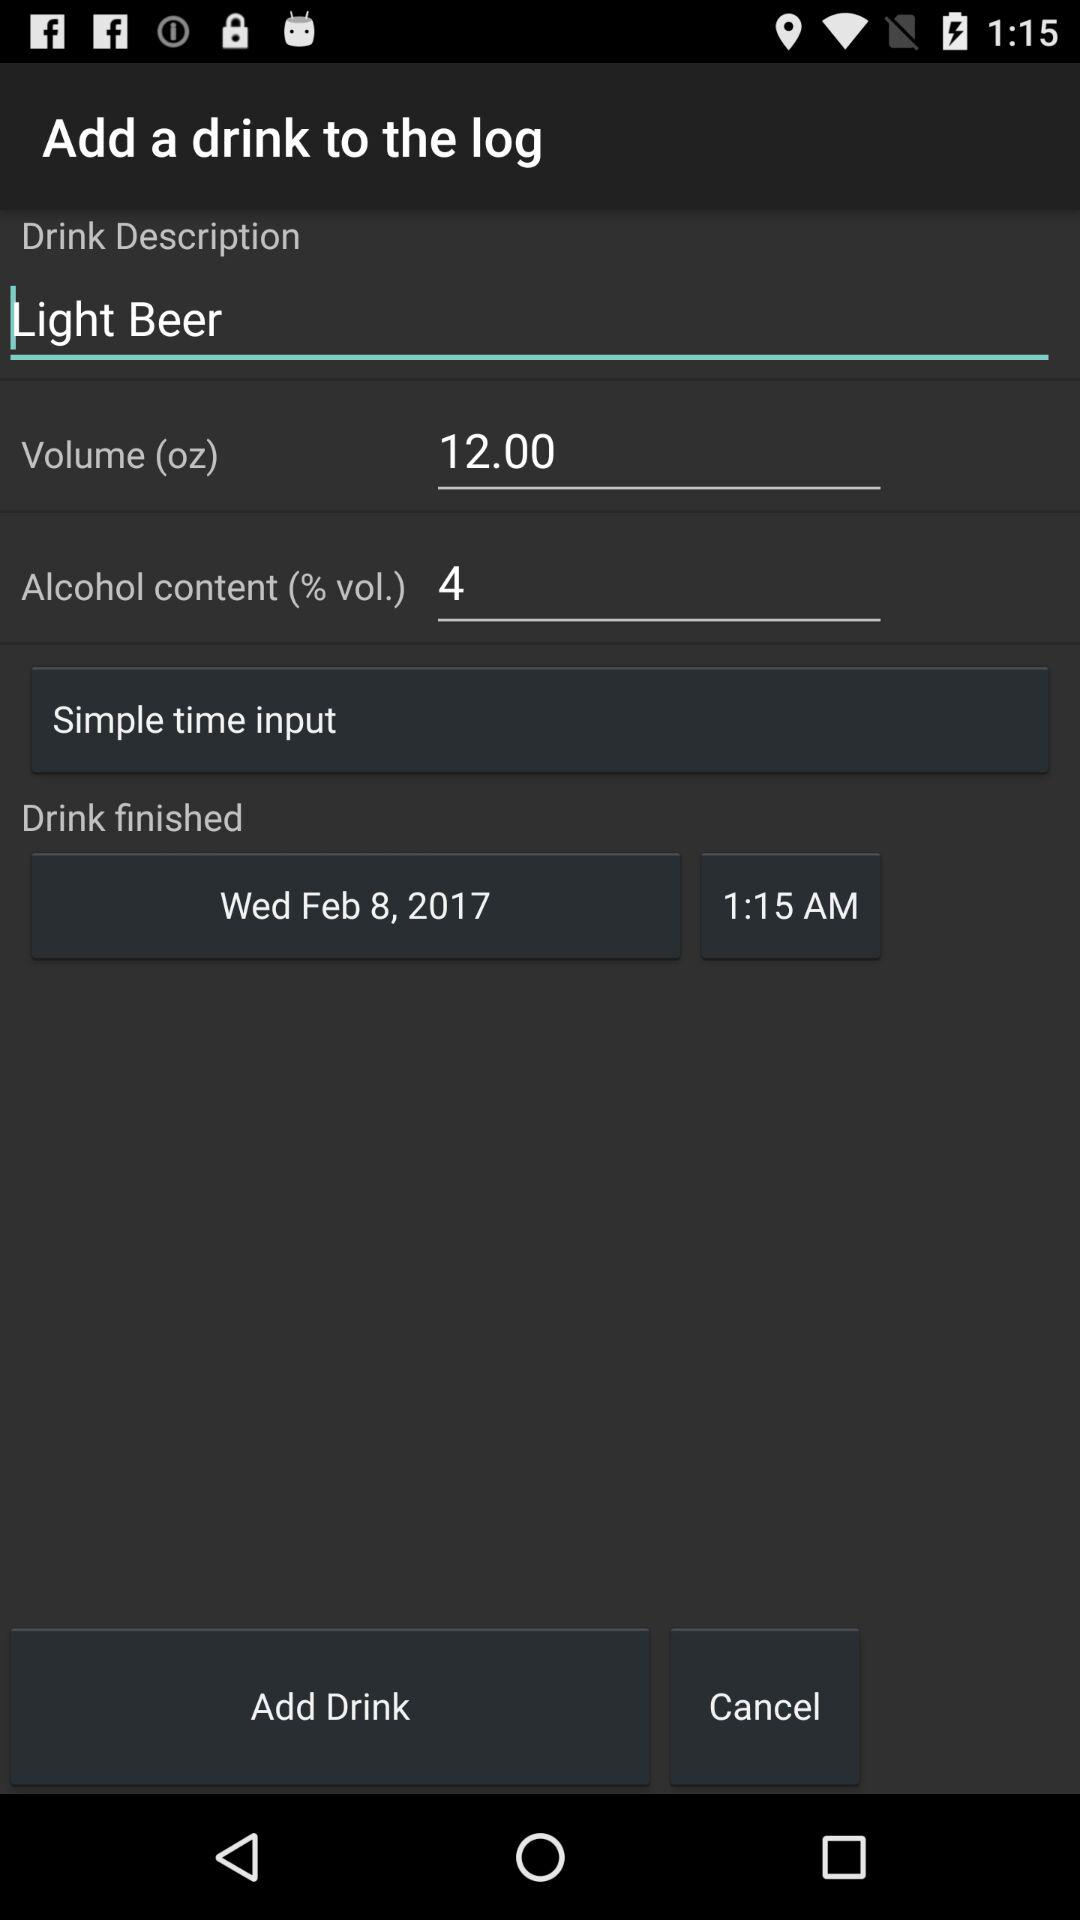What is the alcohol content of the drink in percentage points?
Answer the question using a single word or phrase. 4 